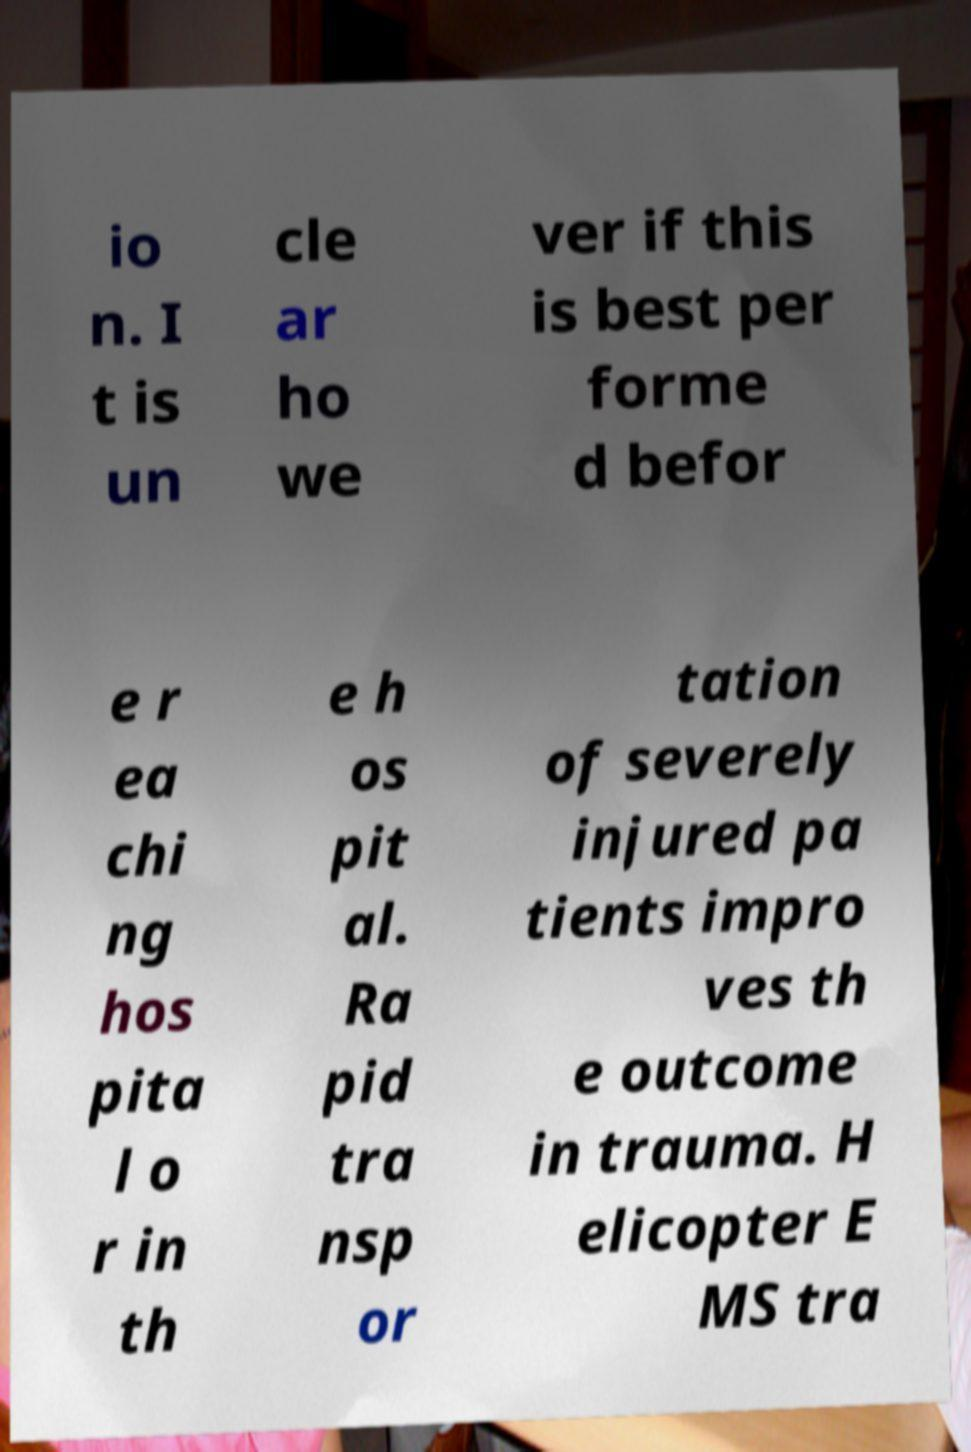Please identify and transcribe the text found in this image. io n. I t is un cle ar ho we ver if this is best per forme d befor e r ea chi ng hos pita l o r in th e h os pit al. Ra pid tra nsp or tation of severely injured pa tients impro ves th e outcome in trauma. H elicopter E MS tra 